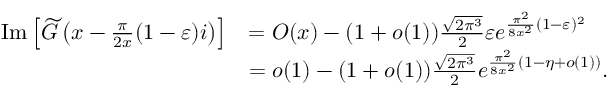<formula> <loc_0><loc_0><loc_500><loc_500>\begin{array} { r l } { I m \left [ \widetilde { G } \left ( x - \frac { \pi } { 2 x } ( 1 - \varepsilon ) i \right ) \right ] } & { = O ( x ) - ( 1 + o ( 1 ) ) \frac { \sqrt { 2 \pi ^ { 3 } } } { 2 } \varepsilon e ^ { \frac { \pi ^ { 2 } } { 8 x ^ { 2 } } ( 1 - \varepsilon ) ^ { 2 } } } \\ & { = o ( 1 ) - ( 1 + o ( 1 ) ) \frac { \sqrt { 2 \pi ^ { 3 } } } { 2 } e ^ { \frac { \pi ^ { 2 } } { 8 x ^ { 2 } } ( 1 - \eta + o ( 1 ) ) } . } \end{array}</formula> 